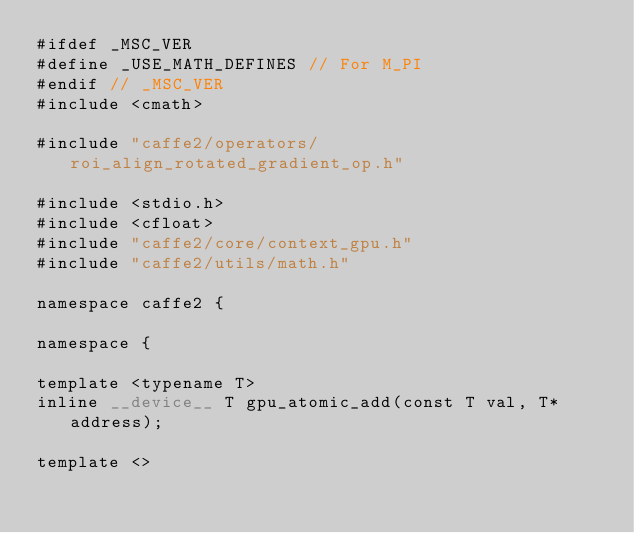Convert code to text. <code><loc_0><loc_0><loc_500><loc_500><_Cuda_>#ifdef _MSC_VER
#define _USE_MATH_DEFINES // For M_PI
#endif // _MSC_VER
#include <cmath>

#include "caffe2/operators/roi_align_rotated_gradient_op.h"

#include <stdio.h>
#include <cfloat>
#include "caffe2/core/context_gpu.h"
#include "caffe2/utils/math.h"

namespace caffe2 {

namespace {

template <typename T>
inline __device__ T gpu_atomic_add(const T val, T* address);

template <></code> 